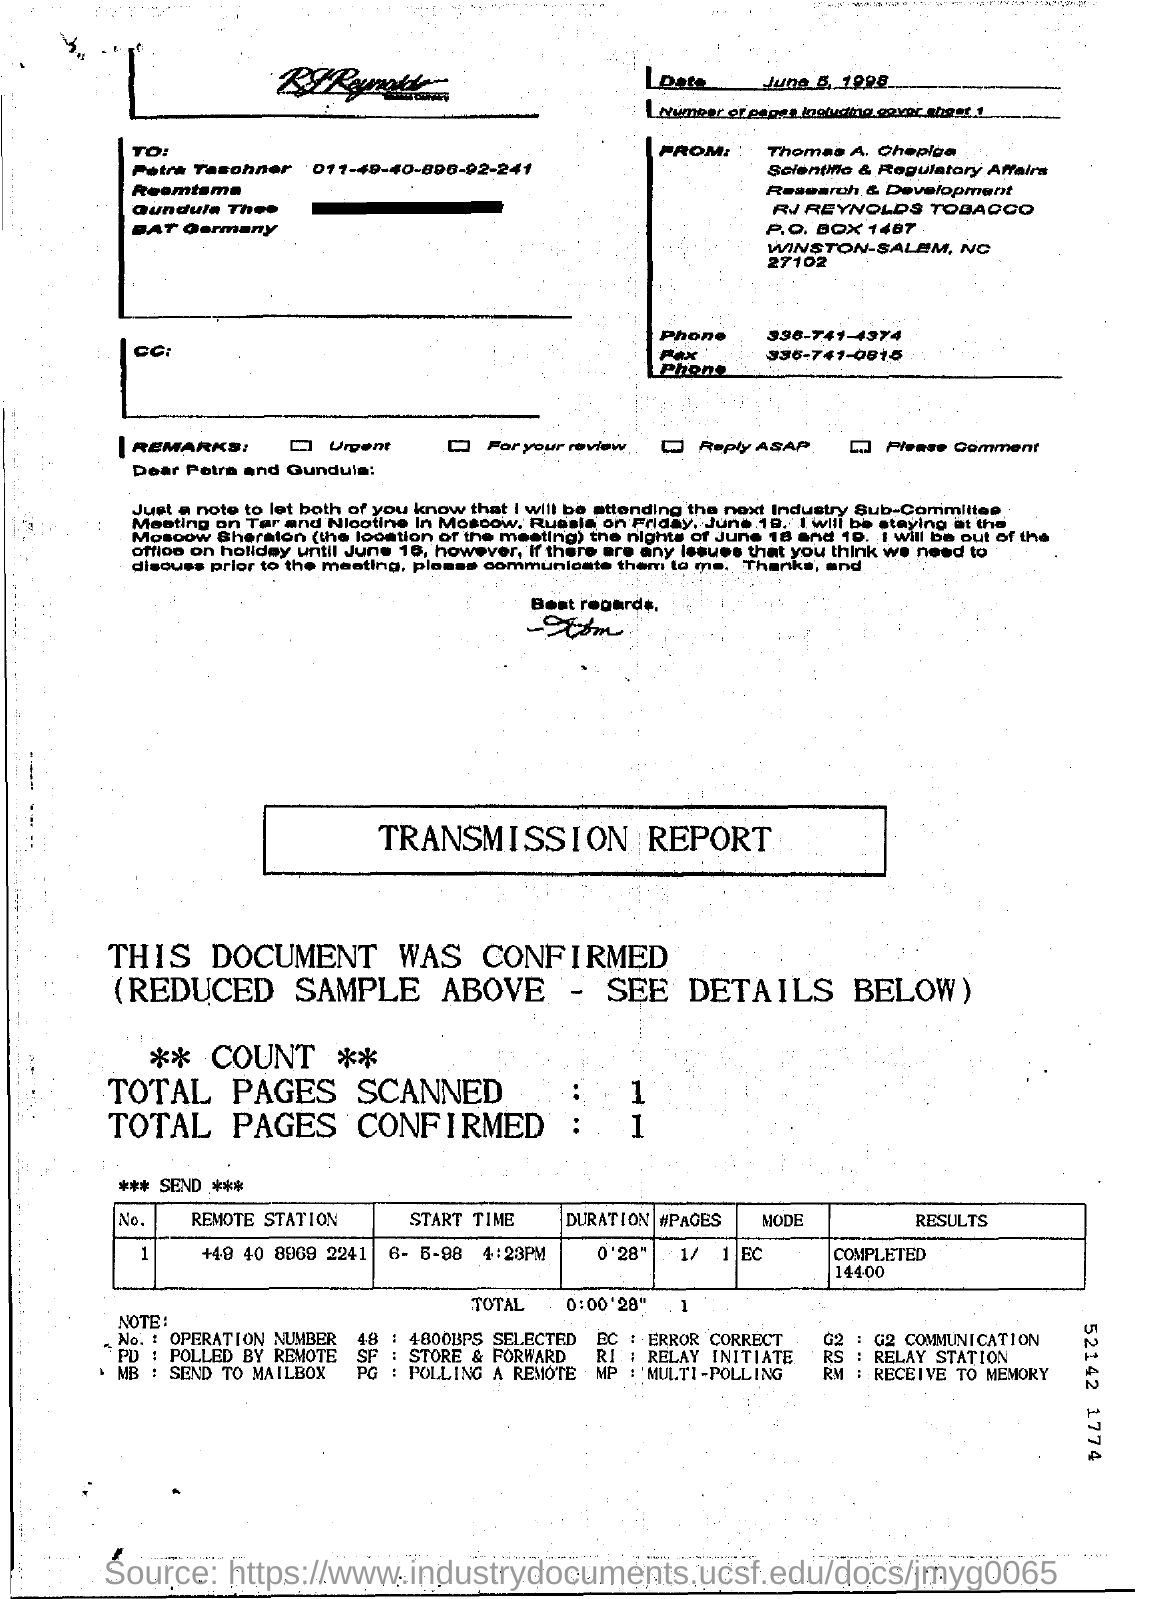What is the date of fax transmission?
Ensure brevity in your answer.  June 5, 1998. What is the number of pages in the fax including cover sheet?
Offer a terse response. 1. Who is the sender of the fax?
Your response must be concise. Thomas A. Chepiga. What is the Fax phone no of Thomas A. Chepiga?
Your answer should be very brief. 336-741-0815. What is the mode given in the transmission report?
Keep it short and to the point. ERROR CORRECT. 